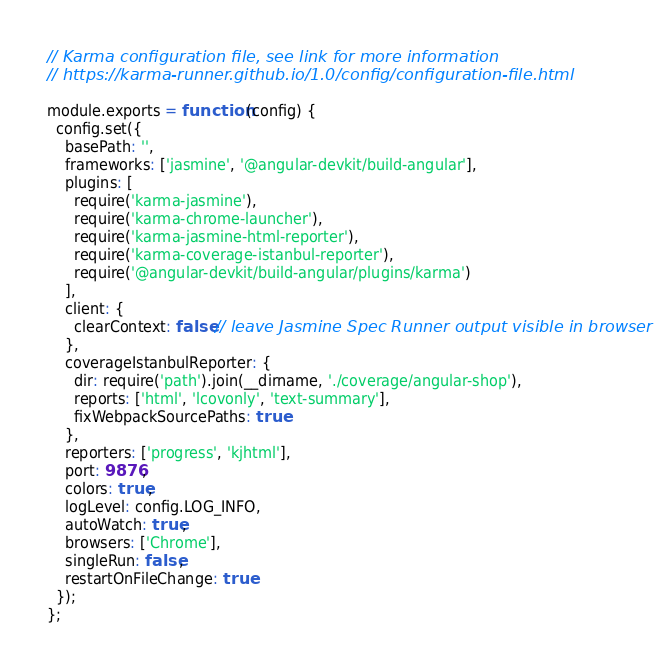Convert code to text. <code><loc_0><loc_0><loc_500><loc_500><_JavaScript_>// Karma configuration file, see link for more information
// https://karma-runner.github.io/1.0/config/configuration-file.html

module.exports = function (config) {
  config.set({
    basePath: '',
    frameworks: ['jasmine', '@angular-devkit/build-angular'],
    plugins: [
      require('karma-jasmine'),
      require('karma-chrome-launcher'),
      require('karma-jasmine-html-reporter'),
      require('karma-coverage-istanbul-reporter'),
      require('@angular-devkit/build-angular/plugins/karma')
    ],
    client: {
      clearContext: false // leave Jasmine Spec Runner output visible in browser
    },
    coverageIstanbulReporter: {
      dir: require('path').join(__dirname, './coverage/angular-shop'),
      reports: ['html', 'lcovonly', 'text-summary'],
      fixWebpackSourcePaths: true
    },
    reporters: ['progress', 'kjhtml'],
    port: 9876,
    colors: true,
    logLevel: config.LOG_INFO,
    autoWatch: true,
    browsers: ['Chrome'],
    singleRun: false,
    restartOnFileChange: true
  });
};
</code> 